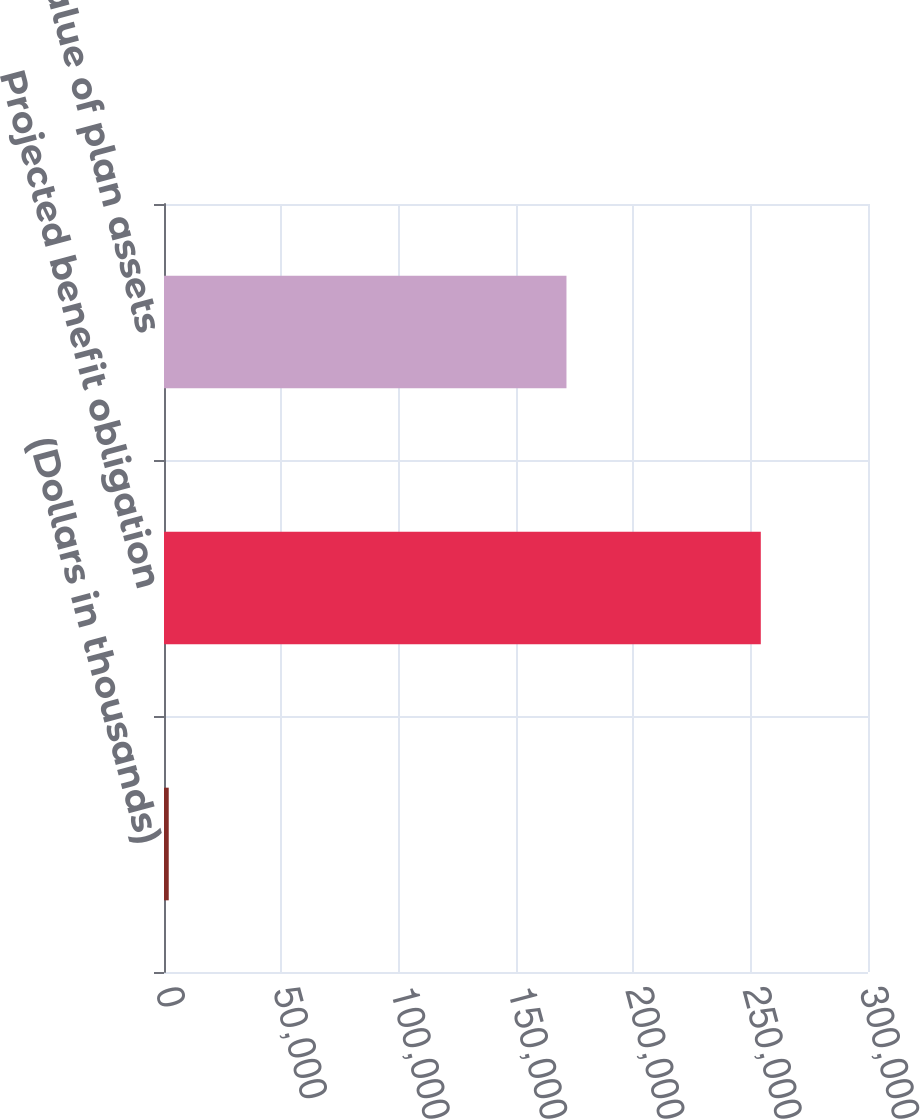<chart> <loc_0><loc_0><loc_500><loc_500><bar_chart><fcel>(Dollars in thousands)<fcel>Projected benefit obligation<fcel>Fair value of plan assets<nl><fcel>2016<fcel>254320<fcel>171506<nl></chart> 